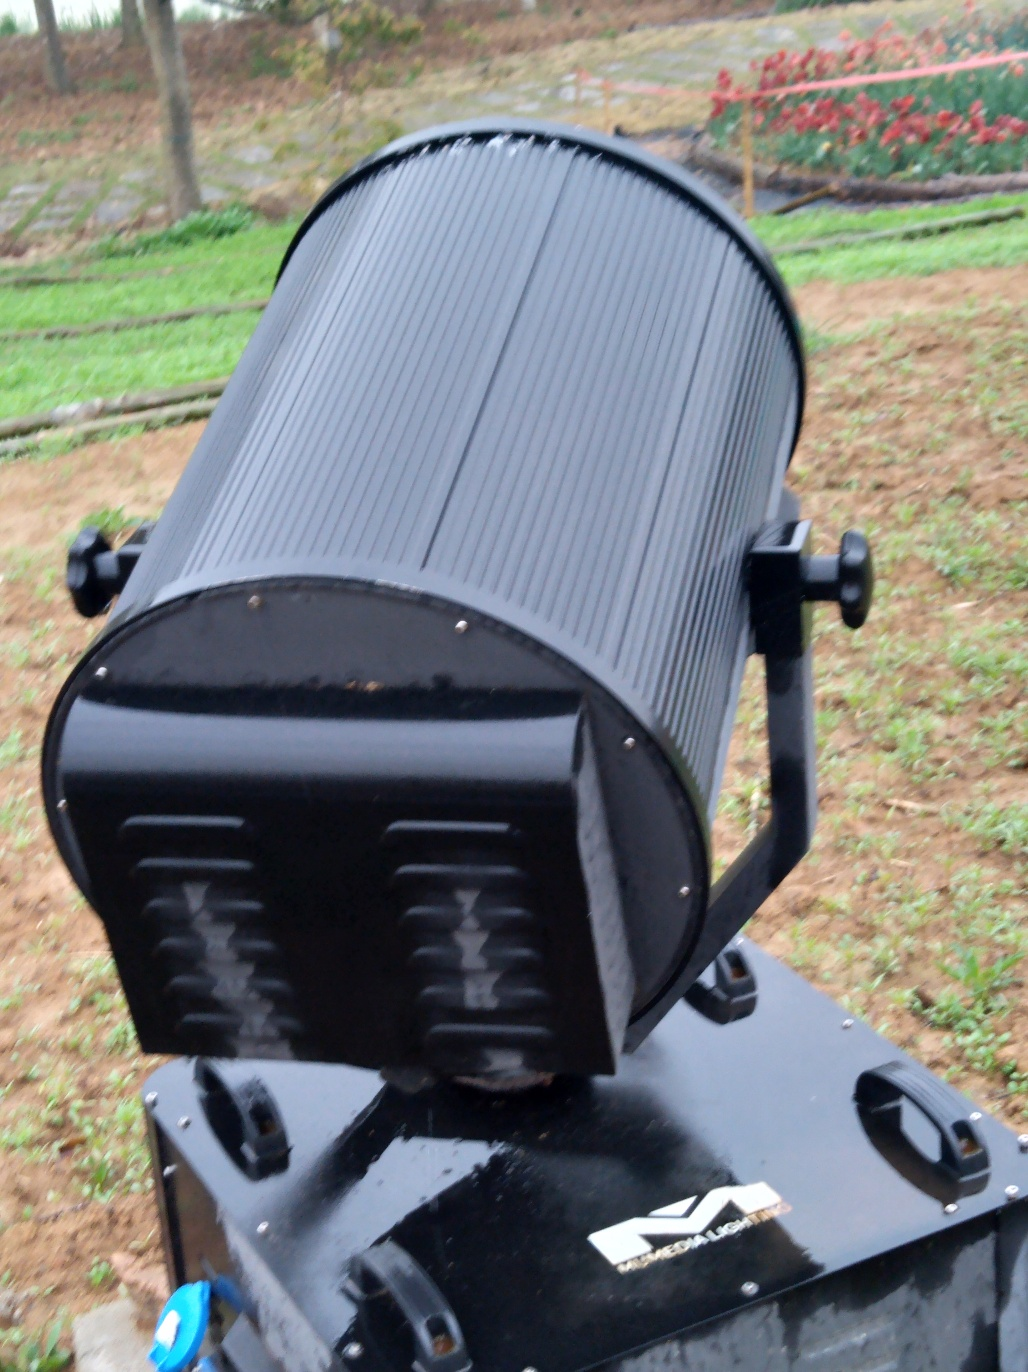What textures and patterns are present on the object's surface? The cylindrical body displays a series of horizontal ridges that add a tactile dimension to its surface. These patterns likely serve a functional purpose, such as reinforcement, or may simply be a byproduct of the manufacturing process. What does the weathering tell us about the object? The weathering indicates that the object has been exposed to outdoor conditions over a period of time. The wear patterns suggest frequent use, which could imply that it’s a reliable component of a larger system that has withstood the test of time and use. 